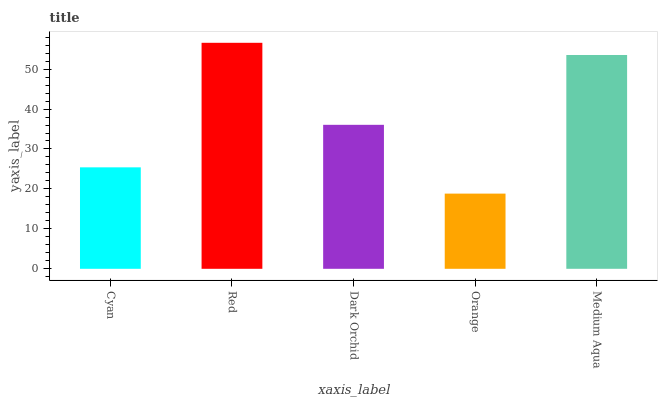Is Orange the minimum?
Answer yes or no. Yes. Is Red the maximum?
Answer yes or no. Yes. Is Dark Orchid the minimum?
Answer yes or no. No. Is Dark Orchid the maximum?
Answer yes or no. No. Is Red greater than Dark Orchid?
Answer yes or no. Yes. Is Dark Orchid less than Red?
Answer yes or no. Yes. Is Dark Orchid greater than Red?
Answer yes or no. No. Is Red less than Dark Orchid?
Answer yes or no. No. Is Dark Orchid the high median?
Answer yes or no. Yes. Is Dark Orchid the low median?
Answer yes or no. Yes. Is Orange the high median?
Answer yes or no. No. Is Orange the low median?
Answer yes or no. No. 